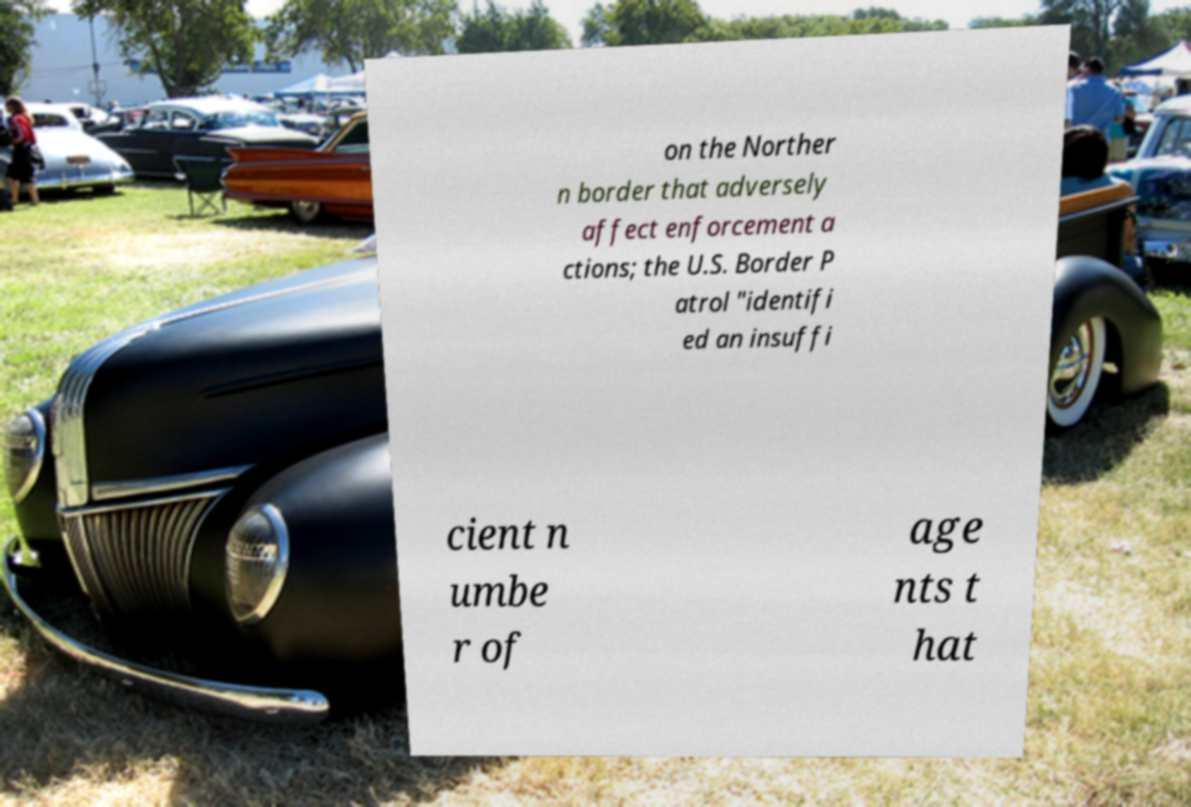Please read and relay the text visible in this image. What does it say? on the Norther n border that adversely affect enforcement a ctions; the U.S. Border P atrol "identifi ed an insuffi cient n umbe r of age nts t hat 